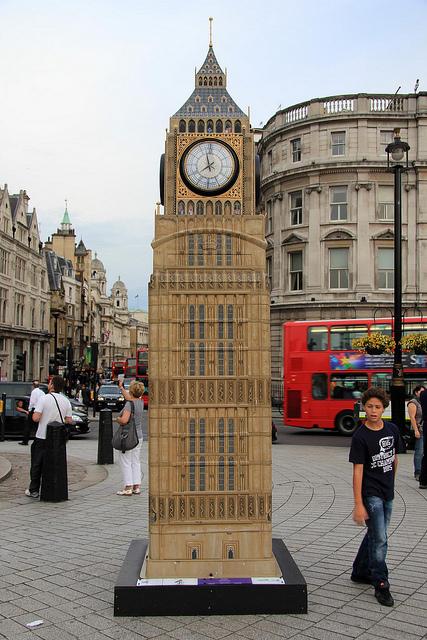What city is this?
Give a very brief answer. London. What is this a miniature of?
Answer briefly. Big ben. What time was the photo taken?
Answer briefly. 11:40. How many people are looking at the statue of a clock?
Write a very short answer. 0. Are there flowers?
Quick response, please. No. What hangs from the light pole?
Give a very brief answer. Flowers. 